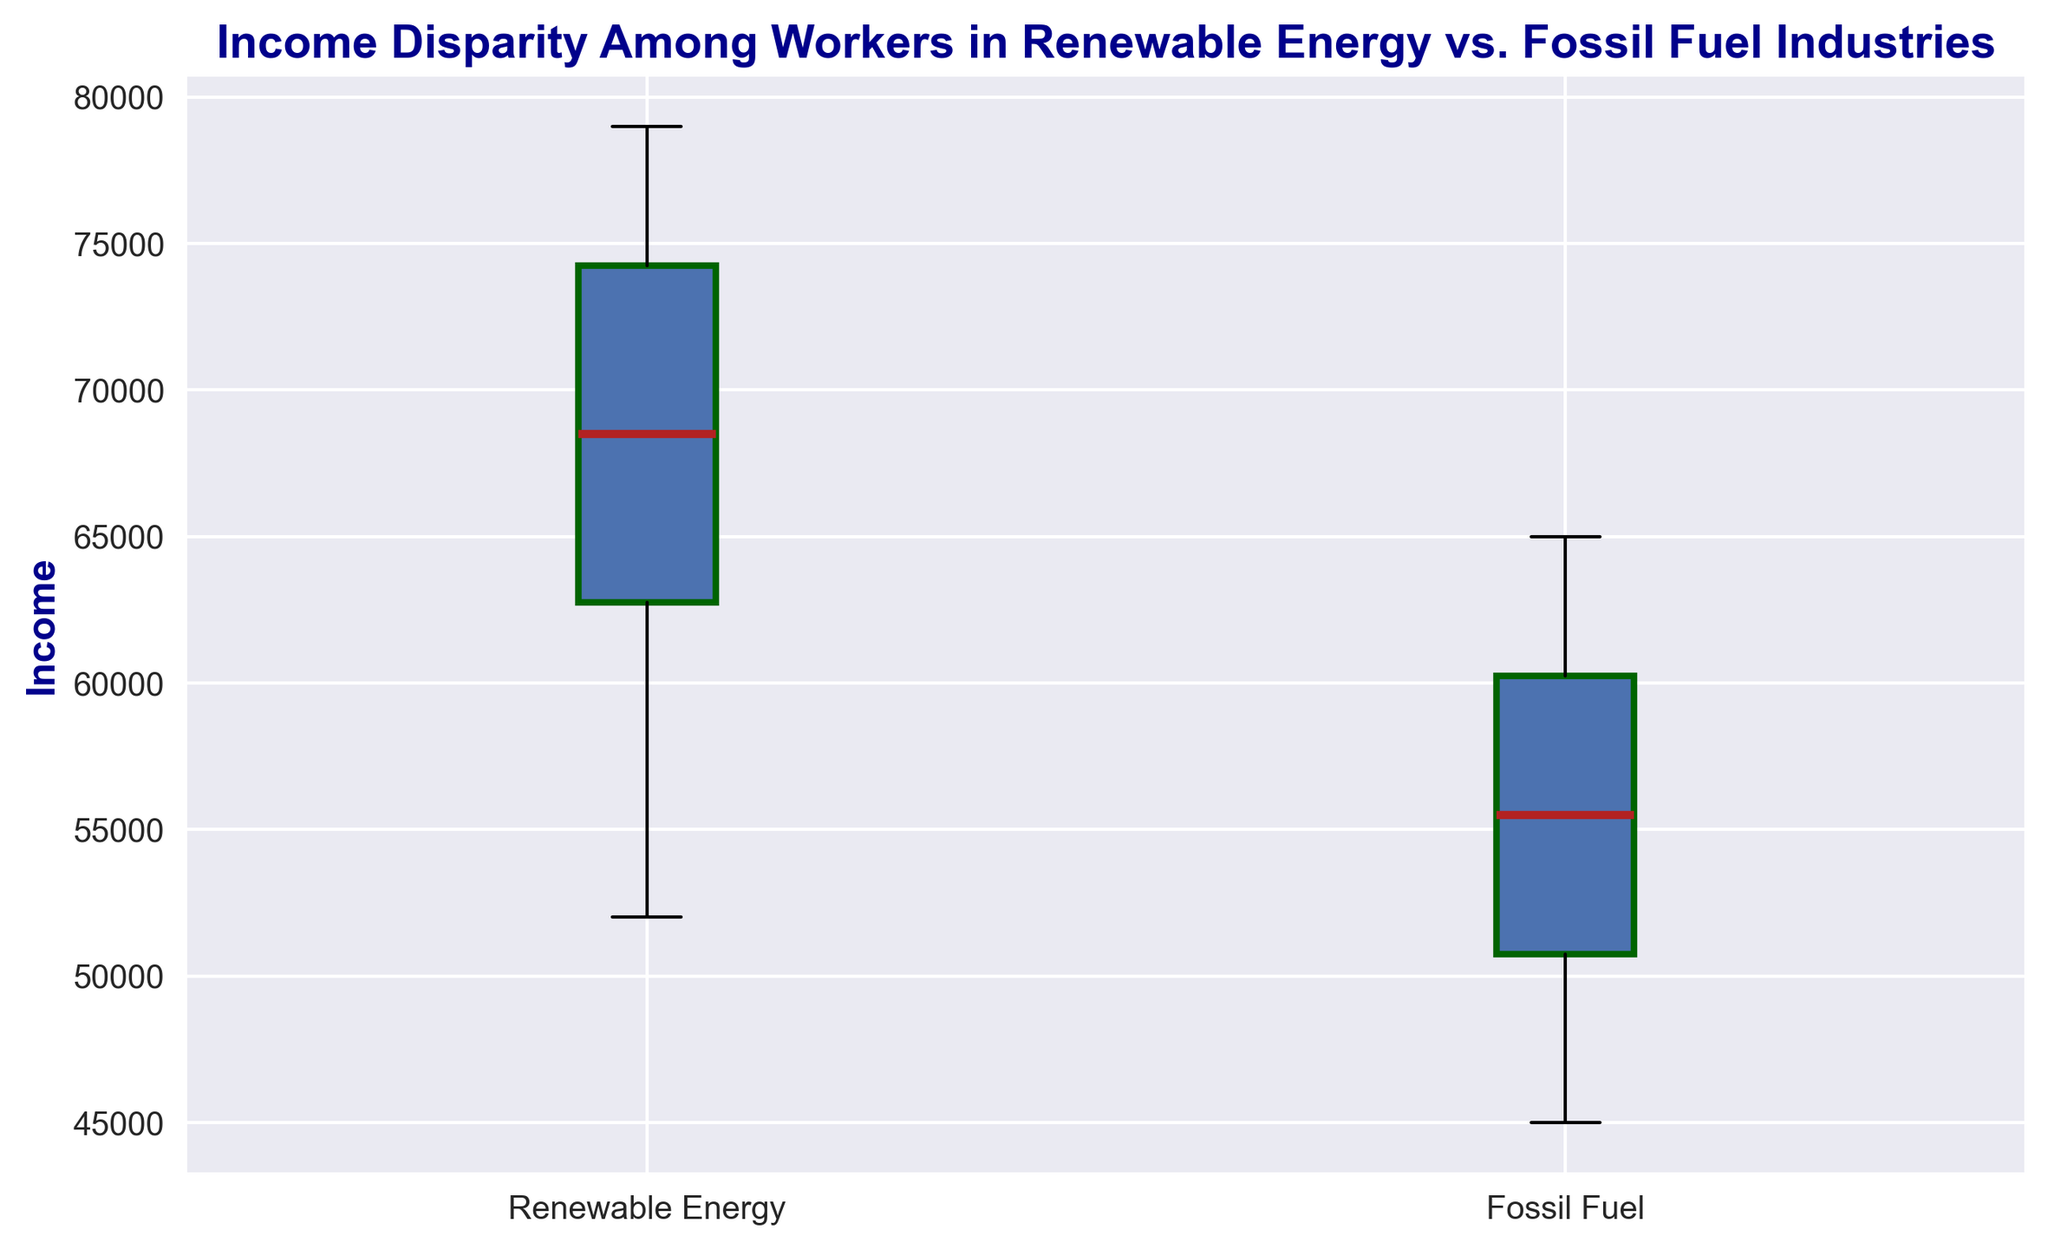What's the median income for workers in the Renewable Energy industry? The median is displayed as the midpoint line inside the renewable income box. It visually represents the middle value when all incomes are sorted in ascending order.
Answer: 70,000 Which industry has a higher interquartile range (IQR) in income, Renewable Energy or Fossil Fuel? The IQR is the difference between the third quartile (Q3) and the first quartile (Q1). Visually, it's the height of the box. Renewable Energy has a taller box compared to Fossil Fuel, indicating a higher IQR.
Answer: Renewable Energy Is the highest income in the Renewable Energy industry greater than the highest income in the Fossil Fuel industry? To determine this, compare the upper whiskers of both box plots. The upper whisker (maximum) in the Renewable Energy box plot goes higher than that of the Fossil Fuel box plot.
Answer: Yes What's the range of incomes in the Fossil Fuel industry? The range is the difference between the maximum and minimum values. For Fossil Fuel, this is the distance between the top and bottom whiskers on the box plot.
Answer: 20,000 Are there any outliers in the income data for both industries? Outliers are typically represented by individual points outside the whiskers of the box plot. Neither the Renewable Energy nor the Fossil Fuel income box plots display any such points.
Answer: No Which industry has a more consistent (less disparate) income distribution? A smaller interquartile range (IQR) and a shorter box indicate more consistency. The Fossil Fuel industry's IQR is smaller, suggesting less disparity in income as compared to Renewable Energy.
Answer: Fossil Fuel How does the median income of workers in the Renewable Energy industry compare to the threshold for the top quartile in the Fossil Fuel industry? The median for Renewable Energy (70,000) is higher than the upper quartile (Q3) mark for Fossil Fuels, which is seen visually lower than 70,000 on the plot.
Answer: Higher What is the difference between the median incomes of the Renewable Energy and Fossil Fuel industries? The median for Renewable Energy is 70,000 and for Fossil Fuel, it's 55,000. The difference is calculated by subtracting the median of Fossil Fuel from Renewable Energy.
Answer: 15,000 If you were a worker in the Renewable Energy industry, what would be your interquartile range (IQR) of income? The IQR is the difference between the 75th percentile (Q3) and the 25th percentile (Q1) within the box plot of the Renewable Energy industry. The third quartile is approximately 75,000 and the first quartile is 62,500. Thus, the IQR is 75,000 - 62,500.
Answer: 12,500 Which industry has a larger income disparity, and how can you tell? Income disparity can be inferred from the length of the box (IQR) and the overall range of the data. The Renewable Energy box is larger and has a wider range, indicating higher disparity.
Answer: Renewable Energy 